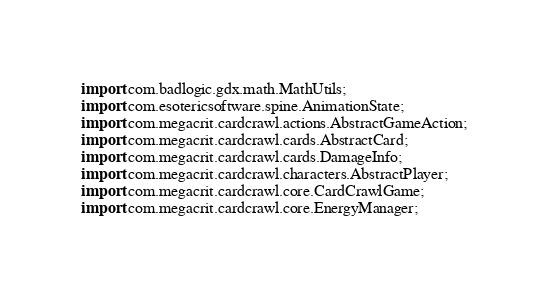Convert code to text. <code><loc_0><loc_0><loc_500><loc_500><_Java_>import com.badlogic.gdx.math.MathUtils;
import com.esotericsoftware.spine.AnimationState;
import com.megacrit.cardcrawl.actions.AbstractGameAction;
import com.megacrit.cardcrawl.cards.AbstractCard;
import com.megacrit.cardcrawl.cards.DamageInfo;
import com.megacrit.cardcrawl.characters.AbstractPlayer;
import com.megacrit.cardcrawl.core.CardCrawlGame;
import com.megacrit.cardcrawl.core.EnergyManager;</code> 